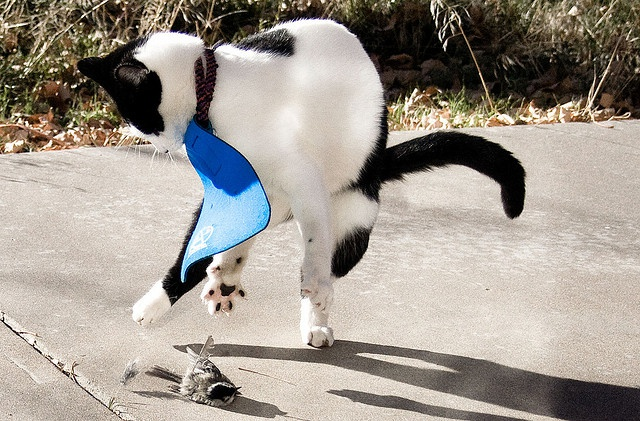Describe the objects in this image and their specific colors. I can see cat in darkgreen, lightgray, black, and darkgray tones and bird in darkgreen, black, gray, darkgray, and lightgray tones in this image. 